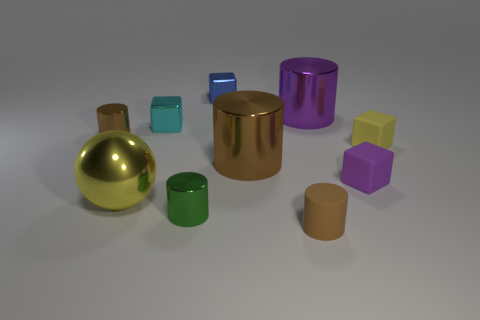Do the tiny cube that is right of the small purple matte thing and the small brown object that is to the left of the small blue metallic object have the same material?
Give a very brief answer. No. What size is the cyan cube that is made of the same material as the large ball?
Provide a succinct answer. Small. There is a small brown thing behind the tiny brown matte thing; what is its shape?
Your answer should be compact. Cylinder. Do the tiny rubber cube behind the tiny purple matte object and the small metallic cylinder that is behind the tiny yellow matte block have the same color?
Your response must be concise. No. The rubber block that is the same color as the shiny sphere is what size?
Keep it short and to the point. Small. Are there any tiny metallic cylinders?
Offer a terse response. Yes. The purple object that is in front of the small brown object that is behind the tiny brown object in front of the tiny green shiny object is what shape?
Your answer should be compact. Cube. There is a brown rubber cylinder; how many blocks are to the left of it?
Ensure brevity in your answer.  2. Is the tiny brown cylinder that is on the left side of the big yellow metallic sphere made of the same material as the big brown object?
Give a very brief answer. Yes. How many other objects are there of the same shape as the small yellow thing?
Ensure brevity in your answer.  3. 